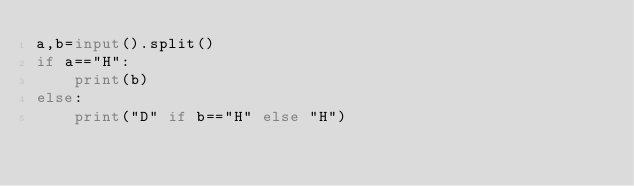Convert code to text. <code><loc_0><loc_0><loc_500><loc_500><_Python_>a,b=input().split()
if a=="H":
    print(b)
else:
    print("D" if b=="H" else "H")</code> 